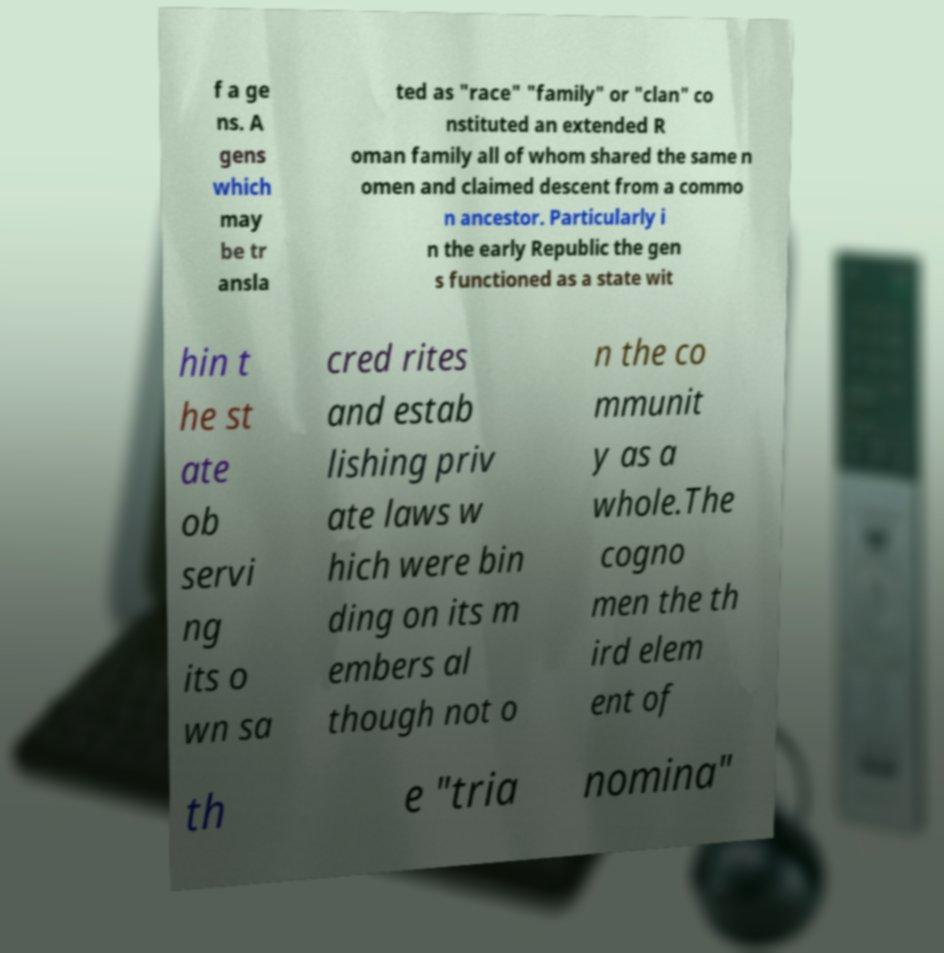For documentation purposes, I need the text within this image transcribed. Could you provide that? f a ge ns. A gens which may be tr ansla ted as "race" "family" or "clan" co nstituted an extended R oman family all of whom shared the same n omen and claimed descent from a commo n ancestor. Particularly i n the early Republic the gen s functioned as a state wit hin t he st ate ob servi ng its o wn sa cred rites and estab lishing priv ate laws w hich were bin ding on its m embers al though not o n the co mmunit y as a whole.The cogno men the th ird elem ent of th e "tria nomina" 